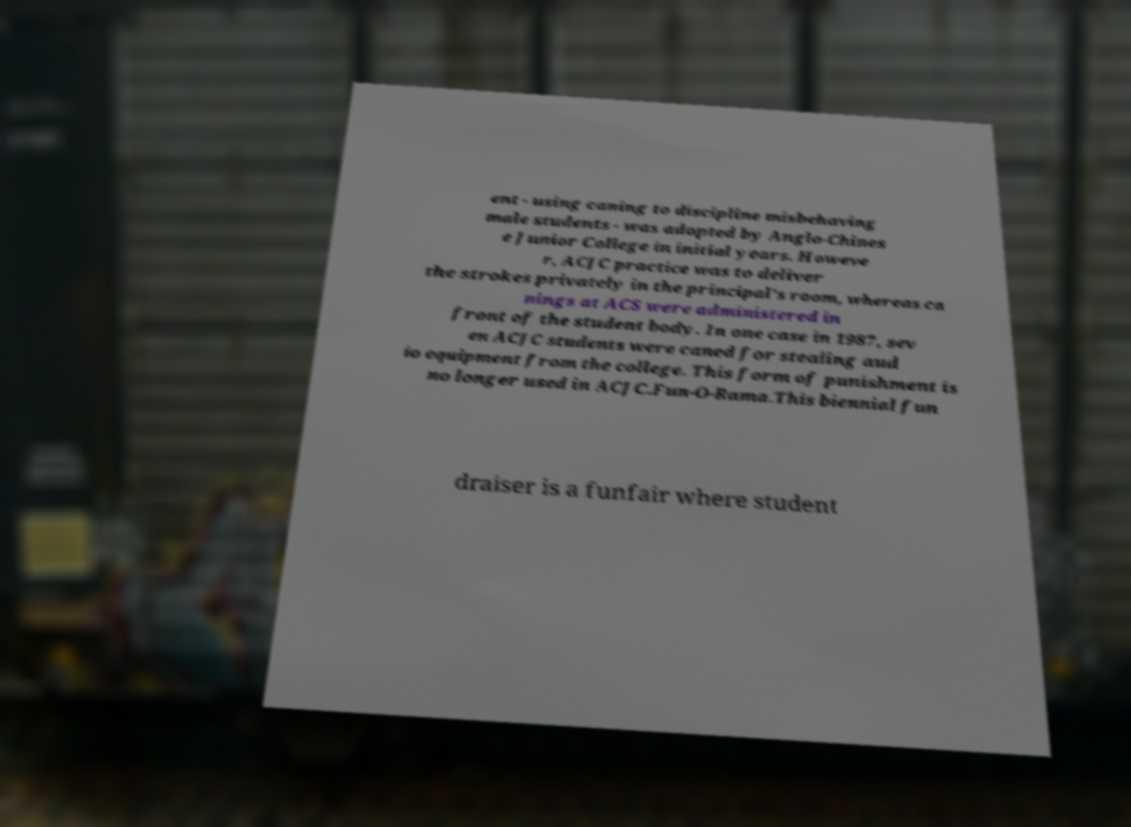What messages or text are displayed in this image? I need them in a readable, typed format. ent - using caning to discipline misbehaving male students - was adopted by Anglo-Chines e Junior College in initial years. Howeve r, ACJC practice was to deliver the strokes privately in the principal's room, whereas ca nings at ACS were administered in front of the student body. In one case in 1987, sev en ACJC students were caned for stealing aud io equipment from the college. This form of punishment is no longer used in ACJC.Fun-O-Rama.This biennial fun draiser is a funfair where student 